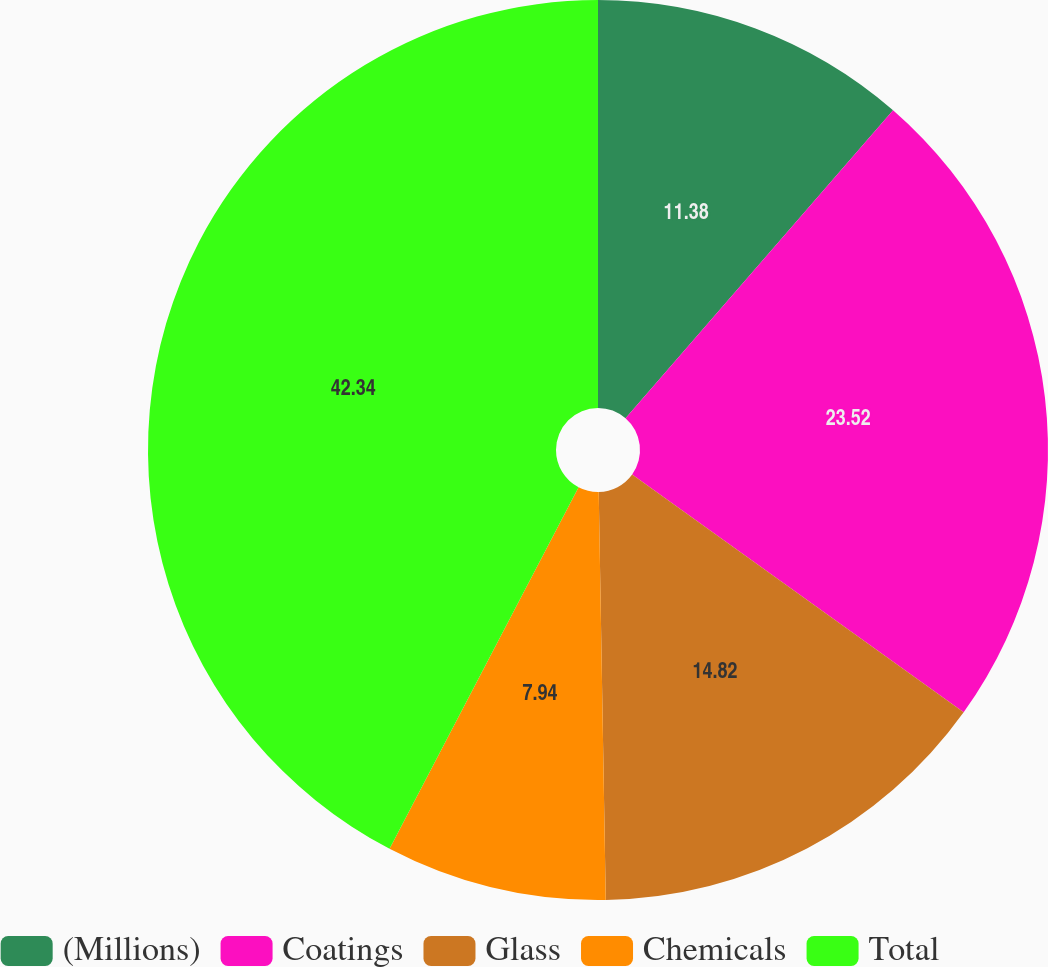<chart> <loc_0><loc_0><loc_500><loc_500><pie_chart><fcel>(Millions)<fcel>Coatings<fcel>Glass<fcel>Chemicals<fcel>Total<nl><fcel>11.38%<fcel>23.52%<fcel>14.82%<fcel>7.94%<fcel>42.33%<nl></chart> 